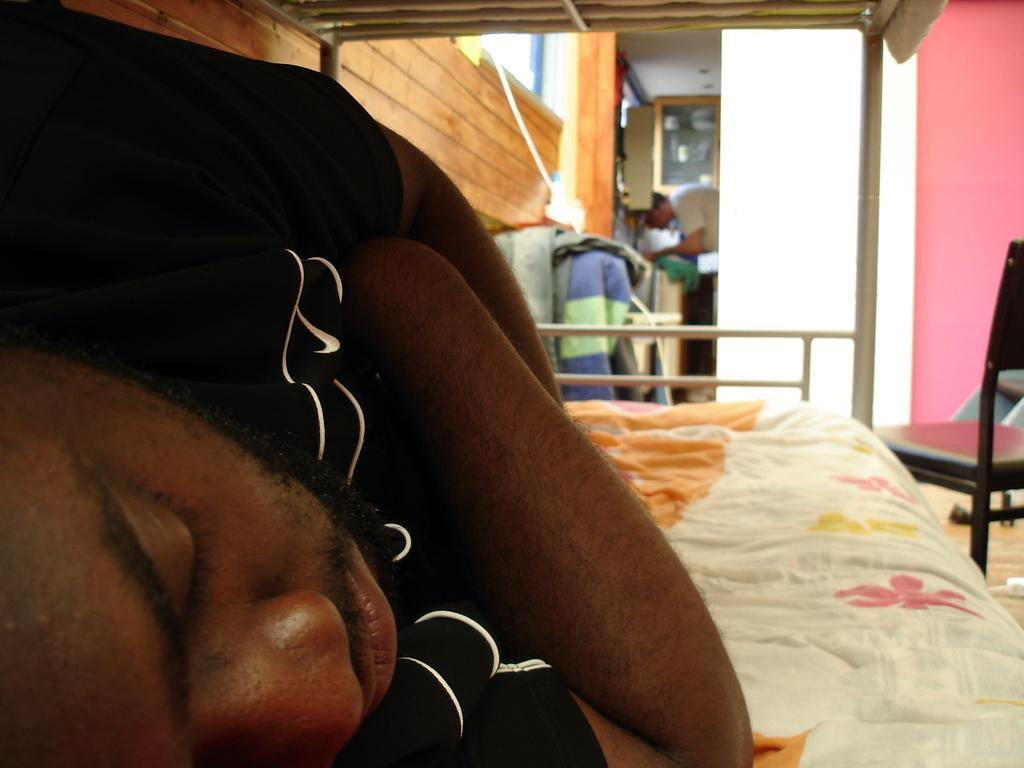Please provide a concise description of this image. In this picture we can see a person with black tee shirt sleeping and folded his hands and behind there is a door in which there is a person and the bed sheet is white, orange, yellow, pink in color. 